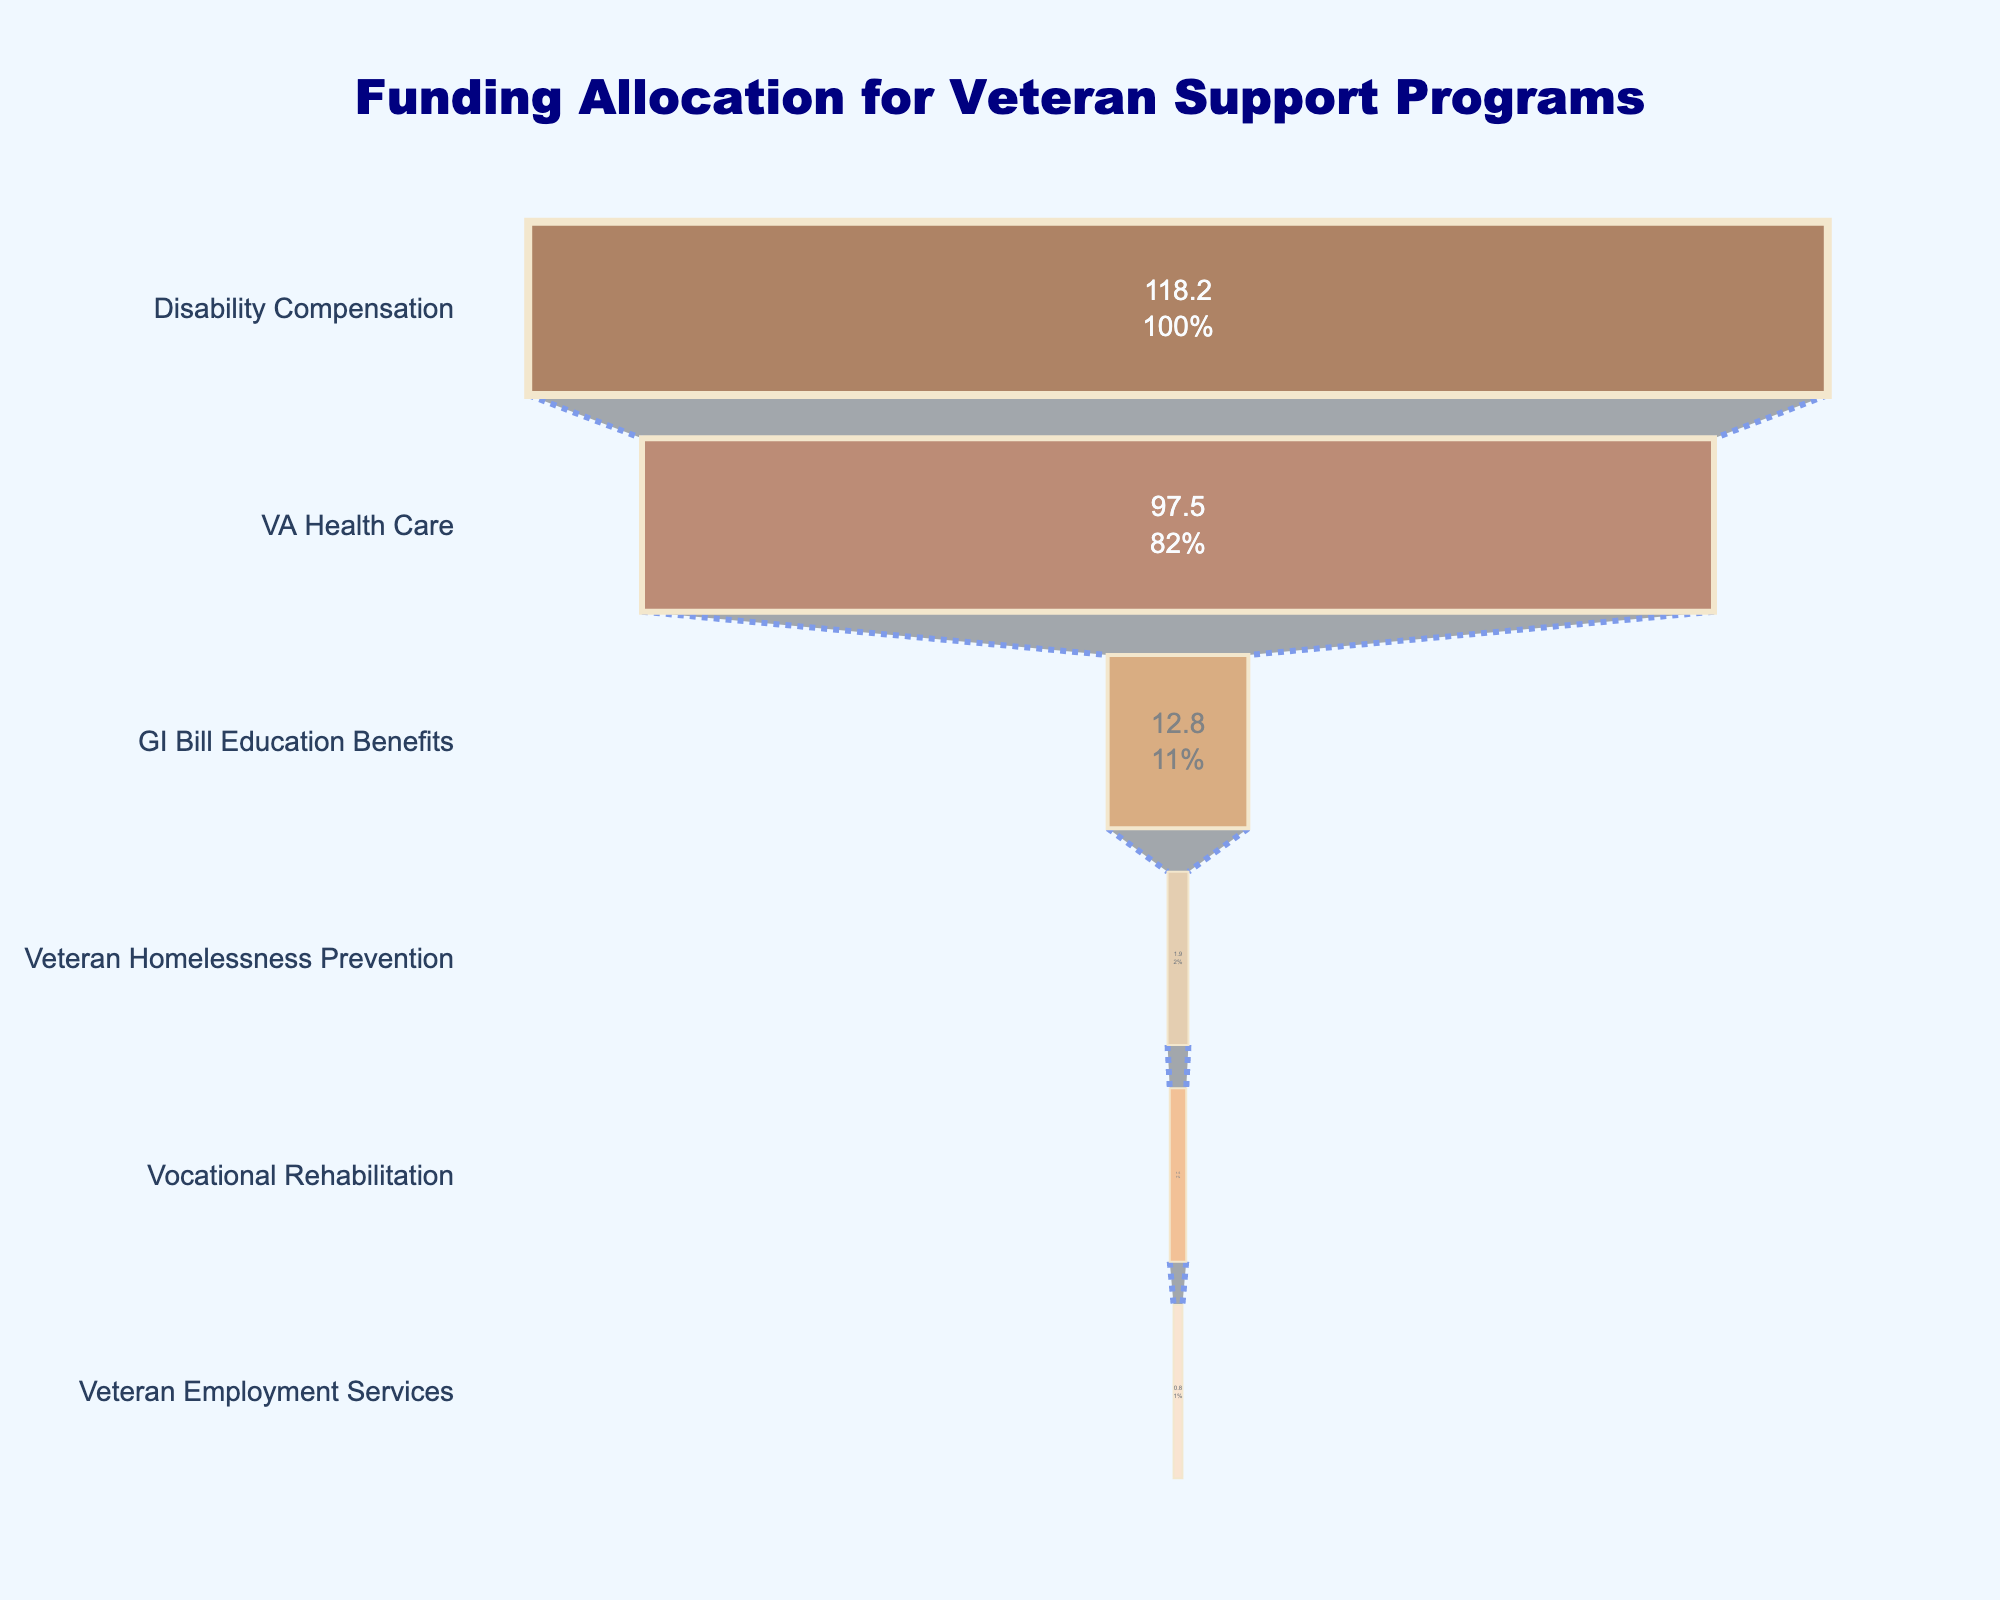What's the largest funding allocation among the veteran support programs? The largest funding allocation can be found by looking at the top of the funnel chart, where the first bar represents the VA Health Care program with the highest allocation of 97.5 billion USD.
Answer: VA Health Care What's the total funding allocation for the VA Health Care and the GI Bill Education Benefits programs? To find the total funding for these two programs, we sum their allocations: 97.5 billion USD (VA Health Care) + 12.8 billion USD (GI Bill Education Benefits) = 110.3 billion USD.
Answer: 110.3 billion USD Which program has the smallest funding allocation? The smallest funding allocation is shown at the bottom of the funnel chart, which represents the Veteran Employment Services with 0.8 billion USD.
Answer: Veteran Employment Services How much more is allocated to Disability Compensation compared to GI Bill Education Benefits? To find the difference, subtract the GI Bill Education Benefits allocation from the Disability Compensation allocation: 118.2 billion USD - 12.8 billion USD = 105.4 billion USD.
Answer: 105.4 billion USD Which two programs combined have a funding allocation greater than 100 billion USD? Adding the allocations of Disability Compensation (118.2 billion USD) and VA Health Care (97.5 billion USD) yields a total of 215.7 billion USD, both of which are greater than 100 billion USD when taken individually or together. Other combinations do not meet the criteria.
Answer: Disability Compensation and VA Health Care What percent of the total funding is allocated to the VA Health Care program? First, find the total funding by summing all program allocations: 97.5 + 12.8 + 118.2 + 1.9 + 1.5 + 0.8 = 232.7 billion USD. Then, calculate the percent for VA Health Care: (97.5 / 232.7) * 100 ≈ 41.9%.
Answer: 41.9% What is the combined funding allocation for all programs excluding Disability Compensation? Sum the allocations for all programs except Disability Compensation: 97.5 + 12.8 + 1.9 + 1.5 + 0.8 = 114.5 billion USD.
Answer: 114.5 billion USD How much more funding does the Veteran Homelessness Prevention program need to match the Vocational Rehabilitation program? Subtract the Veteran Homelessness Prevention allocation from the Vocational Rehabilitation allocation: 1.5 billion USD - 1.9 billion USD = -0.4 billion USD. Therefore, the Veteran Homelessness Prevention program has 0.4 billion USD more than needed.
Answer: -0.4 billion USD 